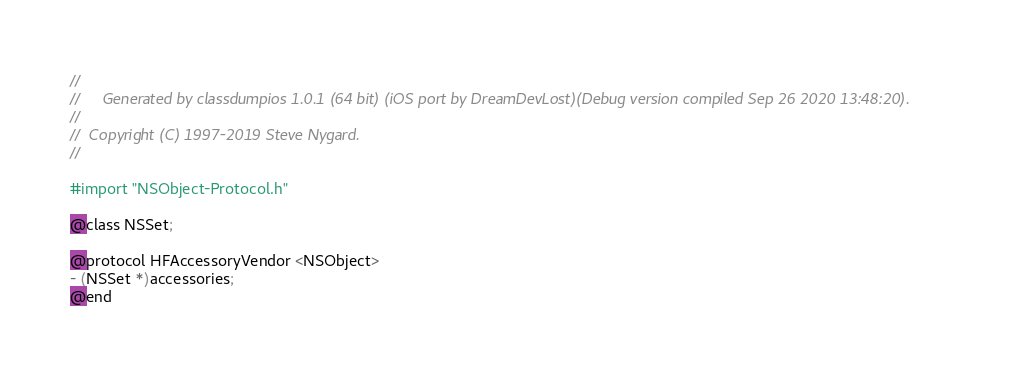Convert code to text. <code><loc_0><loc_0><loc_500><loc_500><_C_>//
//     Generated by classdumpios 1.0.1 (64 bit) (iOS port by DreamDevLost)(Debug version compiled Sep 26 2020 13:48:20).
//
//  Copyright (C) 1997-2019 Steve Nygard.
//

#import "NSObject-Protocol.h"

@class NSSet;

@protocol HFAccessoryVendor <NSObject>
- (NSSet *)accessories;
@end

</code> 